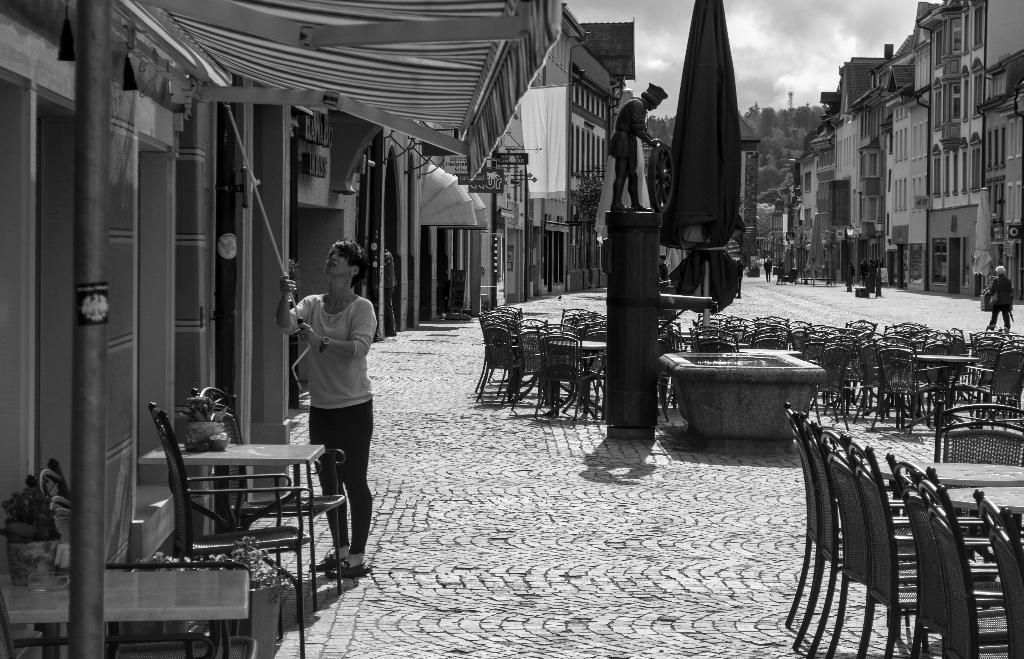How would you summarize this image in a sentence or two? In this image I can see a woman is standing in the front and I can see she is holding a rod. On the both sides of the image I can see number of chairs, few tables, number of buildings, number of boards and on these boards I can see something is written. In the background I can see few people, number of trees, clouds and the sky. In the centre of the image I can see a sculpture and few other things. I can also see this image is black and white in colour. 